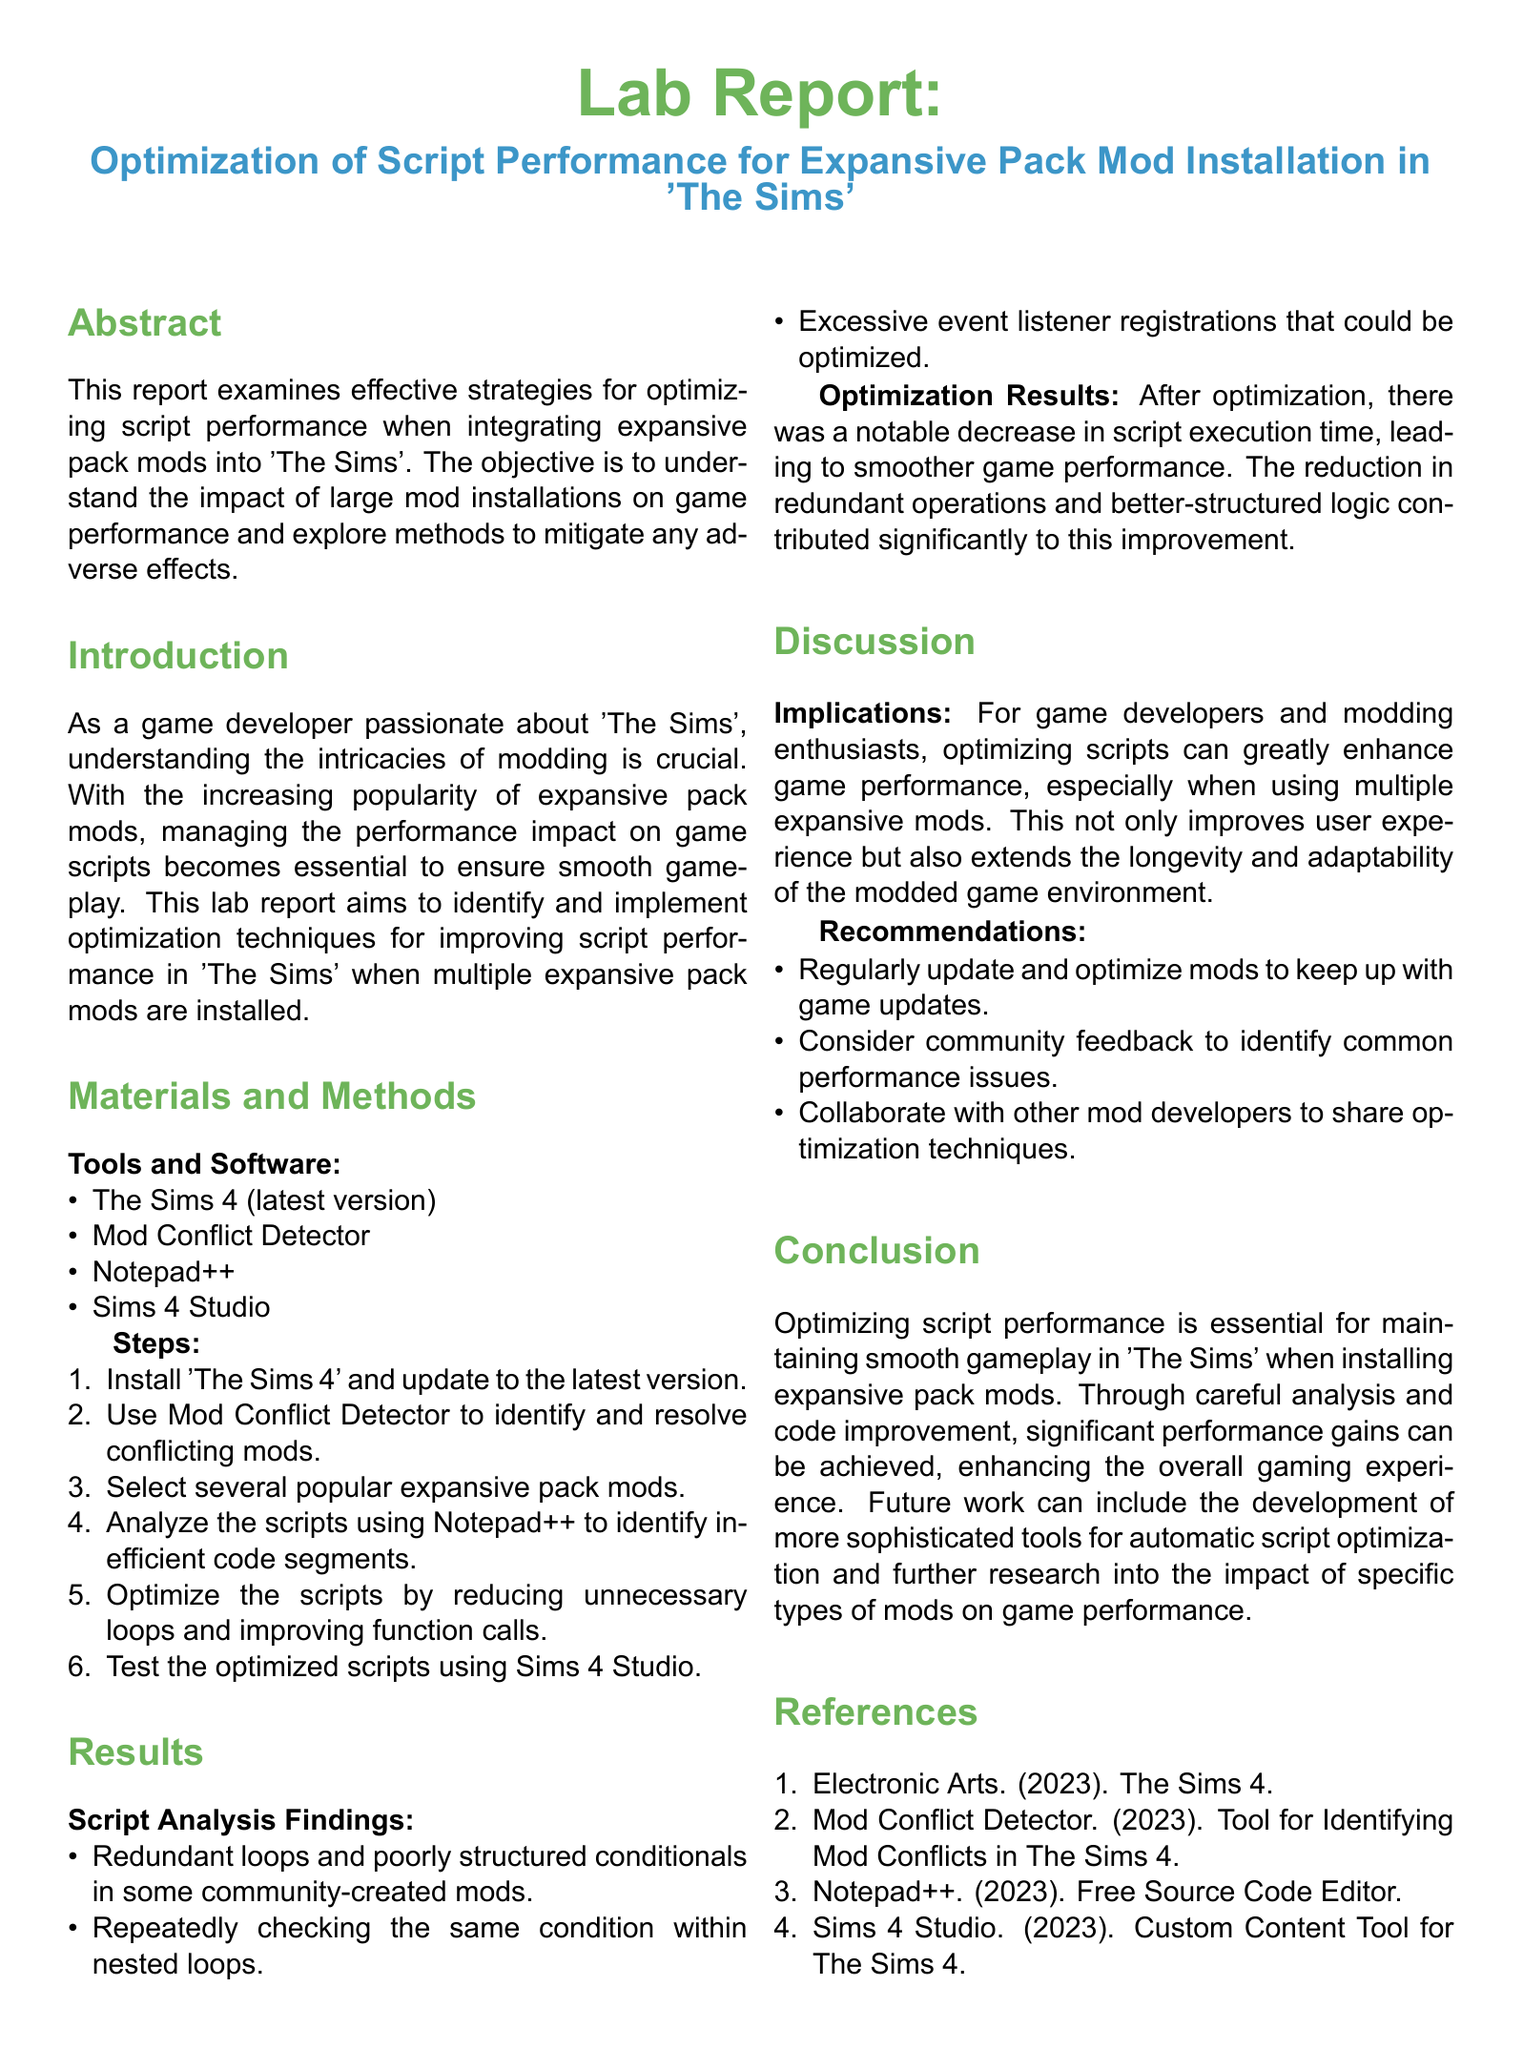What is the main focus of the lab report? The lab report focuses on strategies for optimizing script performance in 'The Sims' with expansive pack mods.
Answer: Optimizing script performance What tools were used in the study? The tools used include The Sims 4, Mod Conflict Detector, Notepad++, and Sims 4 Studio.
Answer: The Sims 4, Mod Conflict Detector, Notepad++, Sims 4 Studio What were the main findings from the script analysis? The analysis identified redundant loops, poorly structured conditionals, and excessive event listener registrations.
Answer: Redundant loops, poor conditionals, excessive listeners What was the impact of optimization on script execution time? After optimization, there was a notable decrease in script execution time, improving performance.
Answer: Notable decrease What is one recommendation made in the report? One recommendation is to regularly update and optimize mods.
Answer: Regularly update and optimize mods What is the conclusion of the lab report? The conclusion emphasizes that optimizing script performance is essential for smooth gameplay with expansive pack mods.
Answer: Essential for smooth gameplay What did the report suggest for future work? The report suggests developing more sophisticated tools for automatic script optimization.
Answer: Develop automatic script optimization tools What color is used for the section titles? The section titles are colored in simgreen.
Answer: Simgreen 